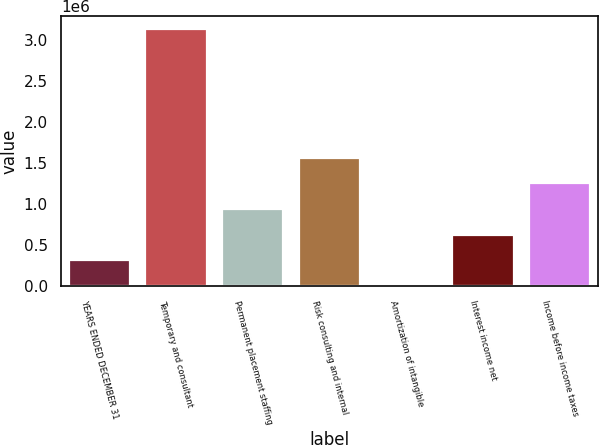<chart> <loc_0><loc_0><loc_500><loc_500><bar_chart><fcel>YEARS ENDED DECEMBER 31<fcel>Temporary and consultant<fcel>Permanent placement staffing<fcel>Risk consulting and internal<fcel>Amortization of intangible<fcel>Interest income net<fcel>Income before income taxes<nl><fcel>314154<fcel>3.13389e+06<fcel>940762<fcel>1.56737e+06<fcel>851<fcel>627458<fcel>1.25406e+06<nl></chart> 